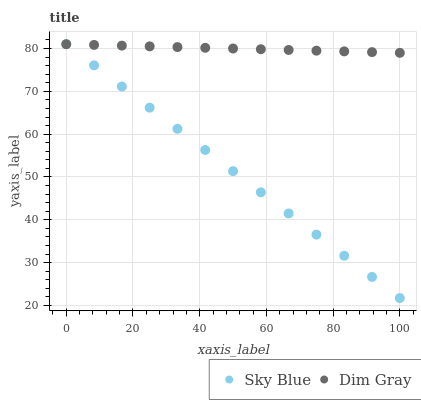Does Sky Blue have the minimum area under the curve?
Answer yes or no. Yes. Does Dim Gray have the maximum area under the curve?
Answer yes or no. Yes. Does Dim Gray have the minimum area under the curve?
Answer yes or no. No. Is Sky Blue the smoothest?
Answer yes or no. Yes. Is Dim Gray the roughest?
Answer yes or no. Yes. Is Dim Gray the smoothest?
Answer yes or no. No. Does Sky Blue have the lowest value?
Answer yes or no. Yes. Does Dim Gray have the lowest value?
Answer yes or no. No. Does Dim Gray have the highest value?
Answer yes or no. Yes. Does Sky Blue intersect Dim Gray?
Answer yes or no. Yes. Is Sky Blue less than Dim Gray?
Answer yes or no. No. Is Sky Blue greater than Dim Gray?
Answer yes or no. No. 